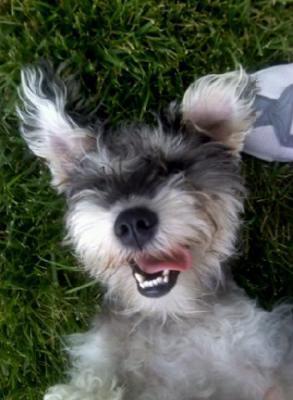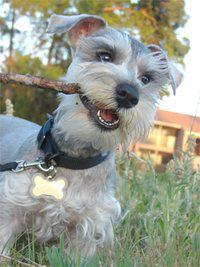The first image is the image on the left, the second image is the image on the right. Given the left and right images, does the statement "At least 4 dogs are standing behind a fence looking out." hold true? Answer yes or no. No. 